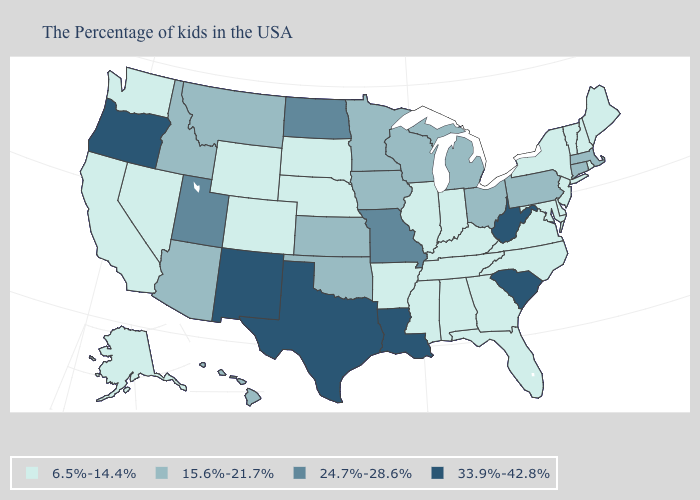Does Louisiana have the highest value in the South?
Concise answer only. Yes. Among the states that border Illinois , which have the lowest value?
Concise answer only. Kentucky, Indiana. What is the value of North Carolina?
Answer briefly. 6.5%-14.4%. What is the value of Utah?
Quick response, please. 24.7%-28.6%. What is the lowest value in the USA?
Short answer required. 6.5%-14.4%. Which states have the lowest value in the West?
Give a very brief answer. Wyoming, Colorado, Nevada, California, Washington, Alaska. Name the states that have a value in the range 6.5%-14.4%?
Concise answer only. Maine, Rhode Island, New Hampshire, Vermont, New York, New Jersey, Delaware, Maryland, Virginia, North Carolina, Florida, Georgia, Kentucky, Indiana, Alabama, Tennessee, Illinois, Mississippi, Arkansas, Nebraska, South Dakota, Wyoming, Colorado, Nevada, California, Washington, Alaska. Does Oregon have the highest value in the USA?
Answer briefly. Yes. What is the lowest value in the West?
Quick response, please. 6.5%-14.4%. Name the states that have a value in the range 6.5%-14.4%?
Be succinct. Maine, Rhode Island, New Hampshire, Vermont, New York, New Jersey, Delaware, Maryland, Virginia, North Carolina, Florida, Georgia, Kentucky, Indiana, Alabama, Tennessee, Illinois, Mississippi, Arkansas, Nebraska, South Dakota, Wyoming, Colorado, Nevada, California, Washington, Alaska. Name the states that have a value in the range 15.6%-21.7%?
Answer briefly. Massachusetts, Connecticut, Pennsylvania, Ohio, Michigan, Wisconsin, Minnesota, Iowa, Kansas, Oklahoma, Montana, Arizona, Idaho, Hawaii. What is the value of Oklahoma?
Give a very brief answer. 15.6%-21.7%. Name the states that have a value in the range 24.7%-28.6%?
Answer briefly. Missouri, North Dakota, Utah. What is the value of Iowa?
Give a very brief answer. 15.6%-21.7%. What is the value of Wyoming?
Concise answer only. 6.5%-14.4%. 